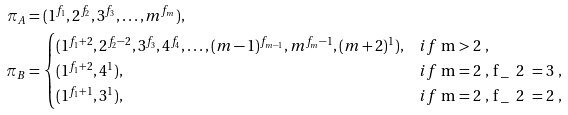Convert formula to latex. <formula><loc_0><loc_0><loc_500><loc_500>\pi _ { A } & = ( 1 ^ { f _ { 1 } } , 2 ^ { f _ { 2 } } , 3 ^ { f _ { 3 } } , \dots , m ^ { f _ { m } } ) , \\ \pi _ { B } & = \begin{cases} ( 1 ^ { f _ { 1 } + 2 } , 2 ^ { f _ { 2 } - 2 } , 3 ^ { f _ { 3 } } , 4 ^ { f _ { 4 } } , \dots , ( m - 1 ) ^ { f _ { m - 1 } } , m ^ { f _ { m } - 1 } , ( m + 2 ) ^ { 1 } ) , & i f $ m > 2 $ , \\ ( 1 ^ { f _ { 1 } + 2 } , 4 ^ { 1 } ) , & i f $ m = 2 $ , $ f _ { 2 } = 3 $ , \\ ( 1 ^ { f _ { 1 } + 1 } , 3 ^ { 1 } ) , & i f $ m = 2 $ , $ f _ { 2 } = 2 $ , \end{cases}</formula> 